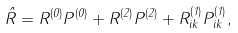Convert formula to latex. <formula><loc_0><loc_0><loc_500><loc_500>\hat { R } = R ^ { ( 0 ) } P ^ { ( 0 ) } + R ^ { ( 2 ) } P ^ { ( 2 ) } + R ^ { ( 1 ) } _ { i k } P ^ { ( 1 ) } _ { i k } ,</formula> 